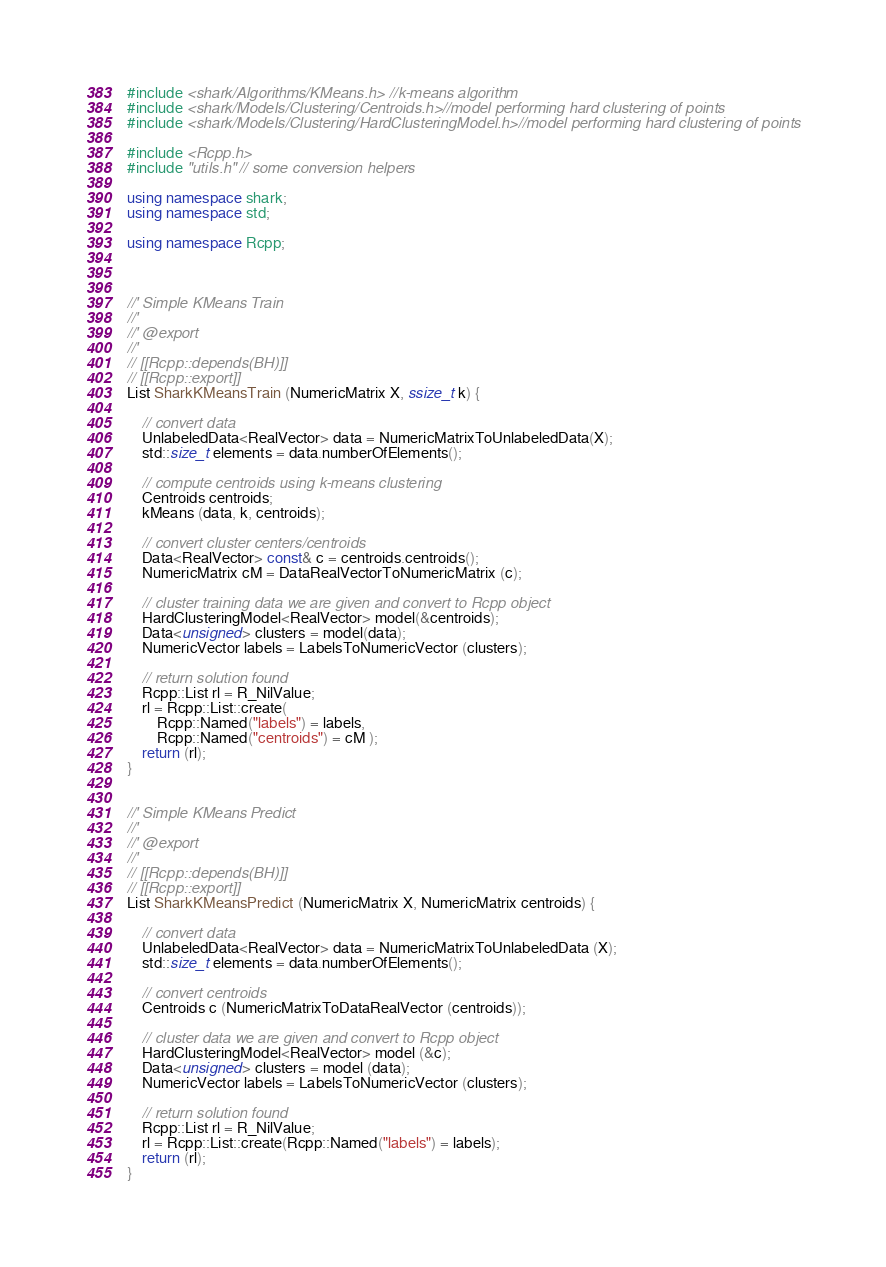Convert code to text. <code><loc_0><loc_0><loc_500><loc_500><_C++_>
#include <shark/Algorithms/KMeans.h> //k-means algorithm
#include <shark/Models/Clustering/Centroids.h>//model performing hard clustering of points
#include <shark/Models/Clustering/HardClusteringModel.h>//model performing hard clustering of points

#include <Rcpp.h>
#include "utils.h" // some conversion helpers

using namespace shark;
using namespace std;

using namespace Rcpp;



//' Simple KMeans Train
//' 
//' @export
//'
// [[Rcpp::depends(BH)]]    
// [[Rcpp::export]]	
List SharkKMeansTrain (NumericMatrix X, ssize_t k) {

	// convert data
	UnlabeledData<RealVector> data = NumericMatrixToUnlabeledData(X);
	std::size_t elements = data.numberOfElements();

	// compute centroids using k-means clustering
	Centroids centroids;
	kMeans (data, k, centroids);
	
	// convert cluster centers/centroids
	Data<RealVector> const& c = centroids.centroids();
	NumericMatrix cM = DataRealVectorToNumericMatrix (c);
	
	// cluster training data we are given and convert to Rcpp object
	HardClusteringModel<RealVector> model(&centroids);
	Data<unsigned> clusters = model(data);
	NumericVector labels = LabelsToNumericVector (clusters);

	// return solution found 
	Rcpp::List rl = R_NilValue;
	rl = Rcpp::List::create(
		Rcpp::Named("labels") = labels,
		Rcpp::Named("centroids") = cM );
	return (rl);
}


//' Simple KMeans Predict
//' 
//' @export
//'
// [[Rcpp::depends(BH)]]    
// [[Rcpp::export]]	
List SharkKMeansPredict (NumericMatrix X, NumericMatrix centroids) {
	
	// convert data
	UnlabeledData<RealVector> data = NumericMatrixToUnlabeledData (X);
	std::size_t elements = data.numberOfElements();
	
	// convert centroids
	Centroids c (NumericMatrixToDataRealVector (centroids));
	
	// cluster data we are given and convert to Rcpp object
	HardClusteringModel<RealVector> model (&c);
	Data<unsigned> clusters = model (data);
	NumericVector labels = LabelsToNumericVector (clusters);
	
	// return solution found 
	Rcpp::List rl = R_NilValue;
	rl = Rcpp::List::create(Rcpp::Named("labels") = labels);
	return (rl);
}

</code> 